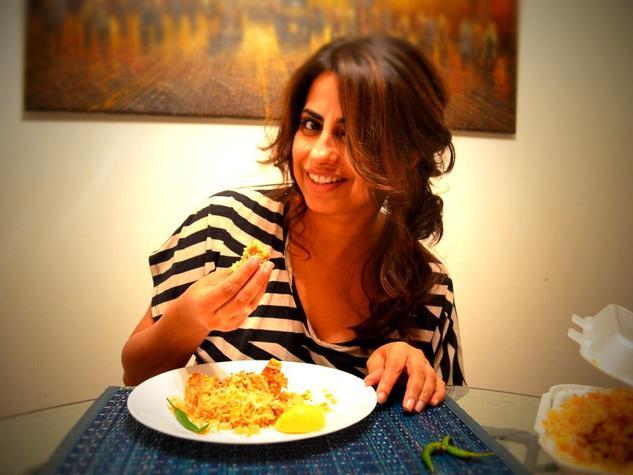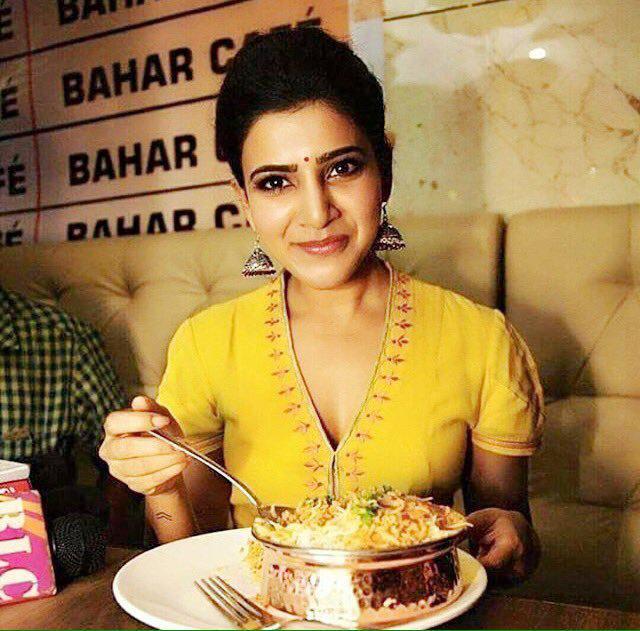The first image is the image on the left, the second image is the image on the right. Analyze the images presented: Is the assertion "The left image shows a young man with dark hair on his head and facial hair, sitting behind a table and raising one hand to his mouth." valid? Answer yes or no. No. The first image is the image on the left, the second image is the image on the right. For the images shown, is this caption "At least one of the pictures shows a person holding a fork or a spoon." true? Answer yes or no. Yes. 